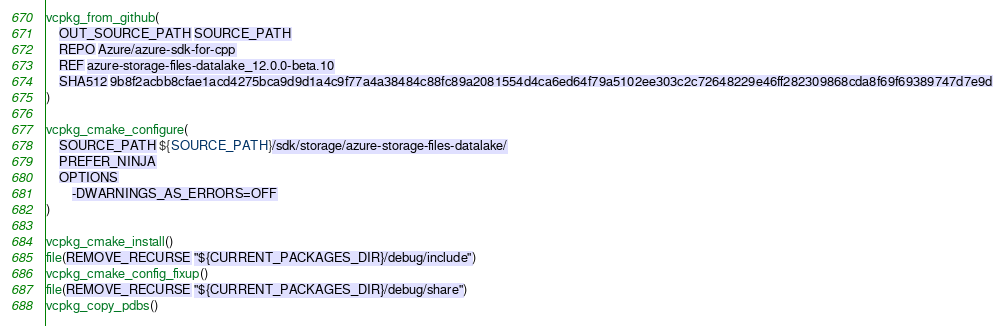<code> <loc_0><loc_0><loc_500><loc_500><_CMake_>vcpkg_from_github(
    OUT_SOURCE_PATH SOURCE_PATH
    REPO Azure/azure-sdk-for-cpp
    REF azure-storage-files-datalake_12.0.0-beta.10
    SHA512 9b8f2acbb8cfae1acd4275bca9d9d1a4c9f77a4a38484c88fc89a2081554d4ca6ed64f79a5102ee303c2c72648229e46ff282309868cda8f69f69389747d7e9d
)

vcpkg_cmake_configure(
    SOURCE_PATH ${SOURCE_PATH}/sdk/storage/azure-storage-files-datalake/
    PREFER_NINJA
    OPTIONS
        -DWARNINGS_AS_ERRORS=OFF
)

vcpkg_cmake_install()
file(REMOVE_RECURSE "${CURRENT_PACKAGES_DIR}/debug/include")
vcpkg_cmake_config_fixup()
file(REMOVE_RECURSE "${CURRENT_PACKAGES_DIR}/debug/share")
vcpkg_copy_pdbs()
</code> 